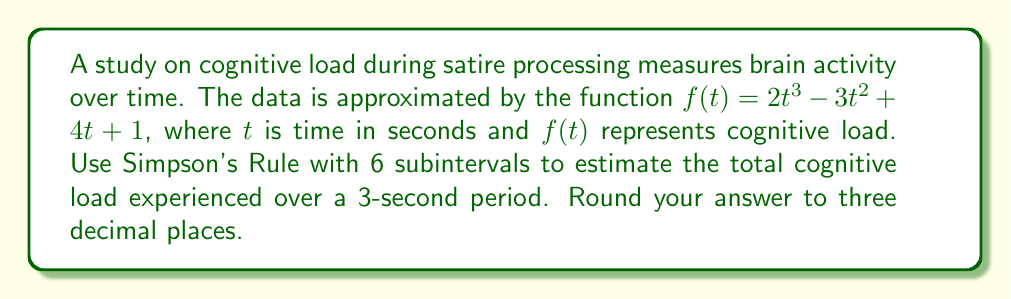Help me with this question. To solve this problem, we'll use Simpson's Rule for numerical integration. Given that we have 6 subintervals over a 3-second period, we'll follow these steps:

1) Simpson's Rule formula:
   $$\int_{a}^{b} f(x) dx \approx \frac{h}{3}[f(x_0) + 4f(x_1) + 2f(x_2) + 4f(x_3) + 2f(x_4) + 4f(x_5) + f(x_6)]$$
   where $h = \frac{b-a}{n}$, $n$ is the number of subintervals, and $a$ and $b$ are the integration limits.

2) Calculate $h$:
   $h = \frac{3-0}{6} = 0.5$

3) Calculate $x_i$ values:
   $x_0 = 0$, $x_1 = 0.5$, $x_2 = 1$, $x_3 = 1.5$, $x_4 = 2$, $x_5 = 2.5$, $x_6 = 3$

4) Calculate $f(x_i)$ values:
   $f(0) = 1$
   $f(0.5) = 2(0.5)^3 - 3(0.5)^2 + 4(0.5) + 1 = 2.125$
   $f(1) = 2(1)^3 - 3(1)^2 + 4(1) + 1 = 4$
   $f(1.5) = 2(1.5)^3 - 3(1.5)^2 + 4(1.5) + 1 = 7.375$
   $f(2) = 2(2)^3 - 3(2)^2 + 4(2) + 1 = 13$
   $f(2.5) = 2(2.5)^3 - 3(2.5)^2 + 4(2.5) + 1 = 21.625$
   $f(3) = 2(3)^3 - 3(3)^2 + 4(3) + 1 = 34$

5) Apply Simpson's Rule:
   $$\frac{0.5}{3}[1 + 4(2.125) + 2(4) + 4(7.375) + 2(13) + 4(21.625) + 34]$$
   $$= \frac{0.5}{3}[1 + 8.5 + 8 + 29.5 + 26 + 86.5 + 34]$$
   $$= \frac{0.5}{3}(193.5)$$
   $$= 32.25$$

6) Round to three decimal places: 32.250
Answer: 32.250 